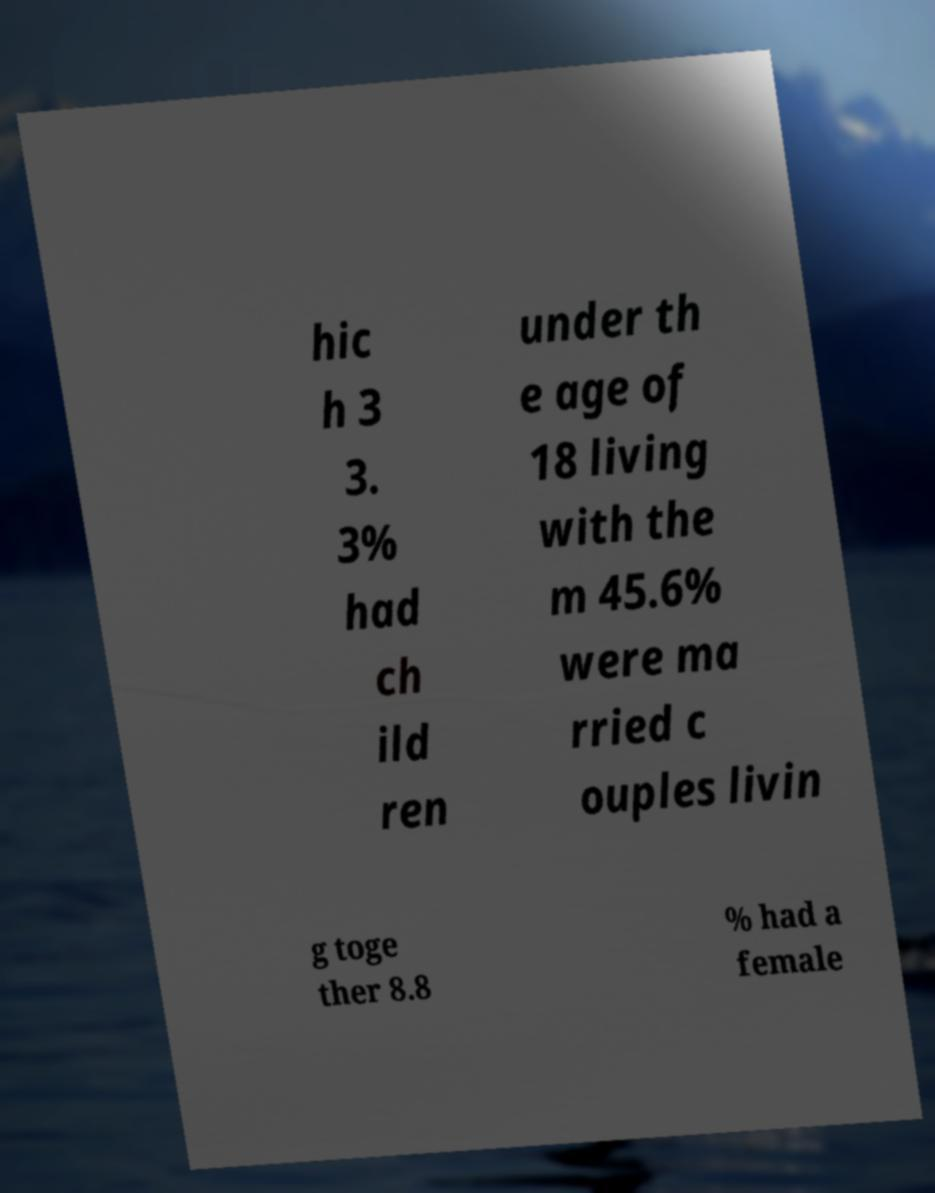I need the written content from this picture converted into text. Can you do that? hic h 3 3. 3% had ch ild ren under th e age of 18 living with the m 45.6% were ma rried c ouples livin g toge ther 8.8 % had a female 